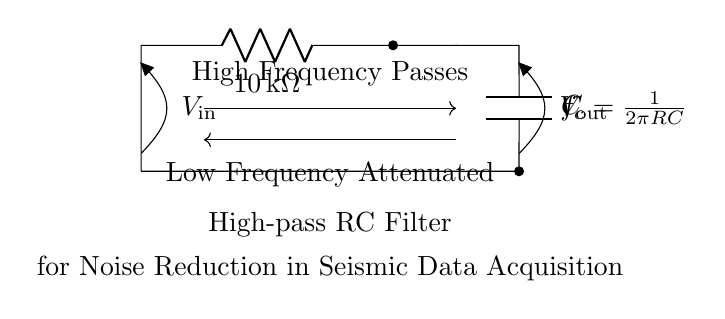What type of filter is represented in this circuit? The circuit diagram shows a high-pass filter because the configuration of the resistor and capacitor allows high frequencies to pass through while attenuating low frequencies.
Answer: High-pass filter What is the value of the resistor in this high-pass filter? The diagram indicates that the resistor value is 10 kilohms, explicitly stated next to the resistor symbol.
Answer: 10 kilohms What is the relationship between frequency and cutoff frequency in this circuit? The expression \( f_c = \frac{1}{2\pi RC} \) shown in the diagram outlines the relationship where \( f_c \) represents the cutoff frequency that separates the passband from the stopband in the frequency response of the filter.
Answer: Cutoff frequency What happens to low frequencies in this high-pass filter? According to the diagram, low frequencies are attenuated, which means that they do not pass through the circuit effectively, leading to reduced amplitude at the output for these frequencies.
Answer: Attenuated Why is a high-pass filter useful in seismic data acquisition? High-pass filters help to remove unwanted low-frequency noise from seismic data, allowing for clearer and more accurate detection of important signal components related to geological features.
Answer: Noise reduction 